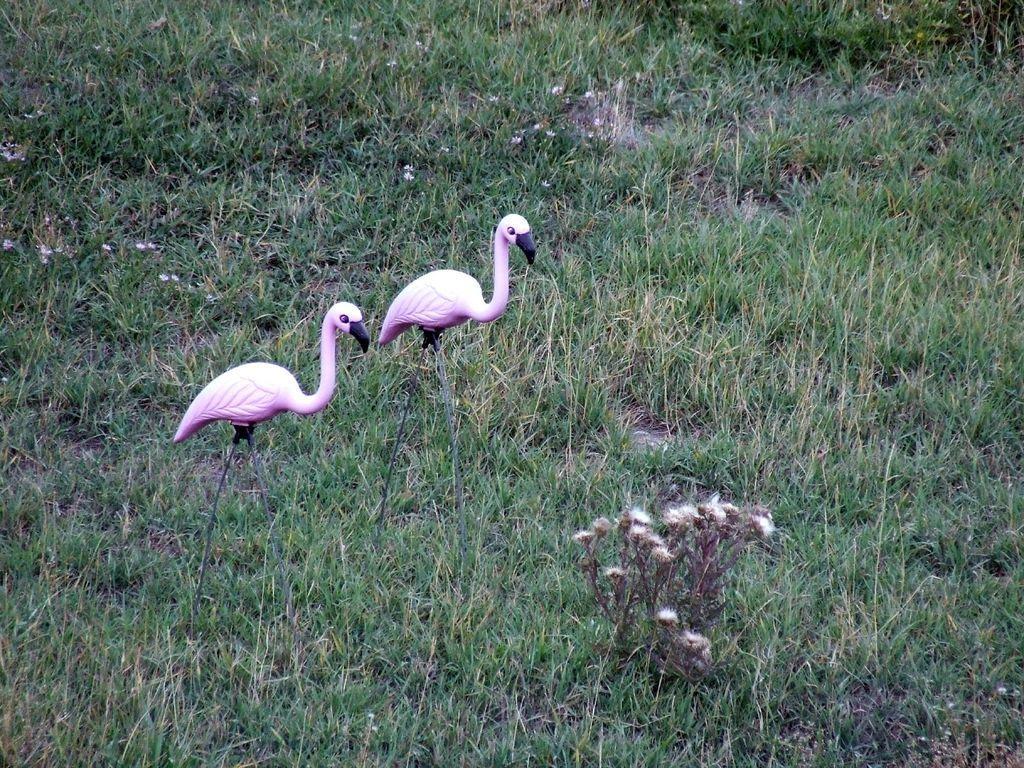Can you describe this image briefly? In this picture we can see birds, plants, grass and flowers. 